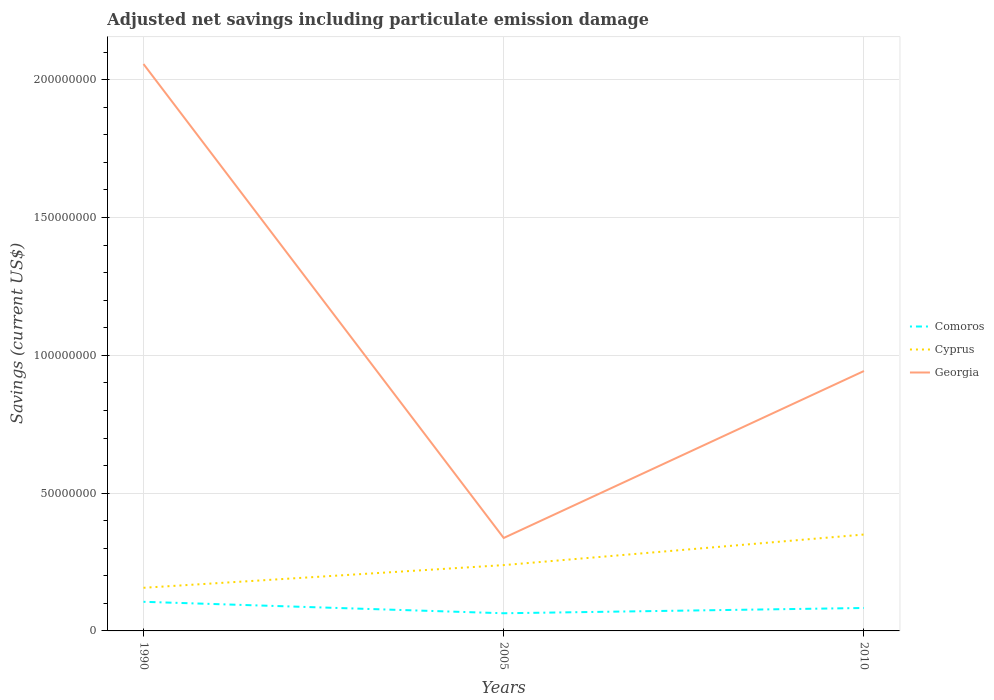Across all years, what is the maximum net savings in Cyprus?
Provide a short and direct response. 1.57e+07. What is the total net savings in Cyprus in the graph?
Provide a short and direct response. -1.93e+07. What is the difference between the highest and the second highest net savings in Comoros?
Keep it short and to the point. 4.16e+06. Is the net savings in Georgia strictly greater than the net savings in Cyprus over the years?
Make the answer very short. No. How many years are there in the graph?
Your response must be concise. 3. Are the values on the major ticks of Y-axis written in scientific E-notation?
Your response must be concise. No. Does the graph contain grids?
Your answer should be very brief. Yes. What is the title of the graph?
Ensure brevity in your answer.  Adjusted net savings including particulate emission damage. Does "Northern Mariana Islands" appear as one of the legend labels in the graph?
Give a very brief answer. No. What is the label or title of the Y-axis?
Make the answer very short. Savings (current US$). What is the Savings (current US$) of Comoros in 1990?
Your answer should be very brief. 1.06e+07. What is the Savings (current US$) in Cyprus in 1990?
Ensure brevity in your answer.  1.57e+07. What is the Savings (current US$) of Georgia in 1990?
Provide a succinct answer. 2.06e+08. What is the Savings (current US$) in Comoros in 2005?
Provide a short and direct response. 6.41e+06. What is the Savings (current US$) of Cyprus in 2005?
Give a very brief answer. 2.39e+07. What is the Savings (current US$) in Georgia in 2005?
Make the answer very short. 3.37e+07. What is the Savings (current US$) of Comoros in 2010?
Give a very brief answer. 8.33e+06. What is the Savings (current US$) in Cyprus in 2010?
Keep it short and to the point. 3.50e+07. What is the Savings (current US$) in Georgia in 2010?
Provide a short and direct response. 9.43e+07. Across all years, what is the maximum Savings (current US$) of Comoros?
Your answer should be compact. 1.06e+07. Across all years, what is the maximum Savings (current US$) in Cyprus?
Provide a short and direct response. 3.50e+07. Across all years, what is the maximum Savings (current US$) in Georgia?
Your response must be concise. 2.06e+08. Across all years, what is the minimum Savings (current US$) of Comoros?
Your response must be concise. 6.41e+06. Across all years, what is the minimum Savings (current US$) of Cyprus?
Give a very brief answer. 1.57e+07. Across all years, what is the minimum Savings (current US$) of Georgia?
Your answer should be very brief. 3.37e+07. What is the total Savings (current US$) in Comoros in the graph?
Your response must be concise. 2.53e+07. What is the total Savings (current US$) of Cyprus in the graph?
Your response must be concise. 7.45e+07. What is the total Savings (current US$) in Georgia in the graph?
Provide a succinct answer. 3.34e+08. What is the difference between the Savings (current US$) in Comoros in 1990 and that in 2005?
Your answer should be compact. 4.16e+06. What is the difference between the Savings (current US$) of Cyprus in 1990 and that in 2005?
Your answer should be compact. -8.23e+06. What is the difference between the Savings (current US$) of Georgia in 1990 and that in 2005?
Provide a short and direct response. 1.72e+08. What is the difference between the Savings (current US$) in Comoros in 1990 and that in 2010?
Offer a terse response. 2.24e+06. What is the difference between the Savings (current US$) in Cyprus in 1990 and that in 2010?
Offer a very short reply. -1.93e+07. What is the difference between the Savings (current US$) of Georgia in 1990 and that in 2010?
Provide a succinct answer. 1.11e+08. What is the difference between the Savings (current US$) of Comoros in 2005 and that in 2010?
Your answer should be compact. -1.92e+06. What is the difference between the Savings (current US$) of Cyprus in 2005 and that in 2010?
Your response must be concise. -1.11e+07. What is the difference between the Savings (current US$) of Georgia in 2005 and that in 2010?
Ensure brevity in your answer.  -6.06e+07. What is the difference between the Savings (current US$) in Comoros in 1990 and the Savings (current US$) in Cyprus in 2005?
Make the answer very short. -1.33e+07. What is the difference between the Savings (current US$) in Comoros in 1990 and the Savings (current US$) in Georgia in 2005?
Provide a succinct answer. -2.32e+07. What is the difference between the Savings (current US$) of Cyprus in 1990 and the Savings (current US$) of Georgia in 2005?
Ensure brevity in your answer.  -1.81e+07. What is the difference between the Savings (current US$) of Comoros in 1990 and the Savings (current US$) of Cyprus in 2010?
Make the answer very short. -2.44e+07. What is the difference between the Savings (current US$) of Comoros in 1990 and the Savings (current US$) of Georgia in 2010?
Your answer should be very brief. -8.37e+07. What is the difference between the Savings (current US$) in Cyprus in 1990 and the Savings (current US$) in Georgia in 2010?
Ensure brevity in your answer.  -7.87e+07. What is the difference between the Savings (current US$) of Comoros in 2005 and the Savings (current US$) of Cyprus in 2010?
Your answer should be compact. -2.86e+07. What is the difference between the Savings (current US$) of Comoros in 2005 and the Savings (current US$) of Georgia in 2010?
Your answer should be very brief. -8.79e+07. What is the difference between the Savings (current US$) in Cyprus in 2005 and the Savings (current US$) in Georgia in 2010?
Give a very brief answer. -7.04e+07. What is the average Savings (current US$) of Comoros per year?
Provide a short and direct response. 8.43e+06. What is the average Savings (current US$) in Cyprus per year?
Your response must be concise. 2.48e+07. What is the average Savings (current US$) of Georgia per year?
Your answer should be compact. 1.11e+08. In the year 1990, what is the difference between the Savings (current US$) in Comoros and Savings (current US$) in Cyprus?
Provide a short and direct response. -5.08e+06. In the year 1990, what is the difference between the Savings (current US$) in Comoros and Savings (current US$) in Georgia?
Your response must be concise. -1.95e+08. In the year 1990, what is the difference between the Savings (current US$) in Cyprus and Savings (current US$) in Georgia?
Offer a very short reply. -1.90e+08. In the year 2005, what is the difference between the Savings (current US$) of Comoros and Savings (current US$) of Cyprus?
Your answer should be very brief. -1.75e+07. In the year 2005, what is the difference between the Savings (current US$) of Comoros and Savings (current US$) of Georgia?
Provide a short and direct response. -2.73e+07. In the year 2005, what is the difference between the Savings (current US$) of Cyprus and Savings (current US$) of Georgia?
Make the answer very short. -9.84e+06. In the year 2010, what is the difference between the Savings (current US$) of Comoros and Savings (current US$) of Cyprus?
Ensure brevity in your answer.  -2.67e+07. In the year 2010, what is the difference between the Savings (current US$) in Comoros and Savings (current US$) in Georgia?
Your answer should be very brief. -8.60e+07. In the year 2010, what is the difference between the Savings (current US$) of Cyprus and Savings (current US$) of Georgia?
Your answer should be very brief. -5.93e+07. What is the ratio of the Savings (current US$) in Comoros in 1990 to that in 2005?
Give a very brief answer. 1.65. What is the ratio of the Savings (current US$) of Cyprus in 1990 to that in 2005?
Your answer should be compact. 0.66. What is the ratio of the Savings (current US$) in Georgia in 1990 to that in 2005?
Your answer should be very brief. 6.1. What is the ratio of the Savings (current US$) of Comoros in 1990 to that in 2010?
Ensure brevity in your answer.  1.27. What is the ratio of the Savings (current US$) of Cyprus in 1990 to that in 2010?
Your answer should be compact. 0.45. What is the ratio of the Savings (current US$) of Georgia in 1990 to that in 2010?
Give a very brief answer. 2.18. What is the ratio of the Savings (current US$) of Comoros in 2005 to that in 2010?
Offer a very short reply. 0.77. What is the ratio of the Savings (current US$) in Cyprus in 2005 to that in 2010?
Offer a terse response. 0.68. What is the ratio of the Savings (current US$) of Georgia in 2005 to that in 2010?
Ensure brevity in your answer.  0.36. What is the difference between the highest and the second highest Savings (current US$) in Comoros?
Your answer should be compact. 2.24e+06. What is the difference between the highest and the second highest Savings (current US$) of Cyprus?
Your response must be concise. 1.11e+07. What is the difference between the highest and the second highest Savings (current US$) in Georgia?
Offer a very short reply. 1.11e+08. What is the difference between the highest and the lowest Savings (current US$) in Comoros?
Ensure brevity in your answer.  4.16e+06. What is the difference between the highest and the lowest Savings (current US$) of Cyprus?
Ensure brevity in your answer.  1.93e+07. What is the difference between the highest and the lowest Savings (current US$) in Georgia?
Give a very brief answer. 1.72e+08. 